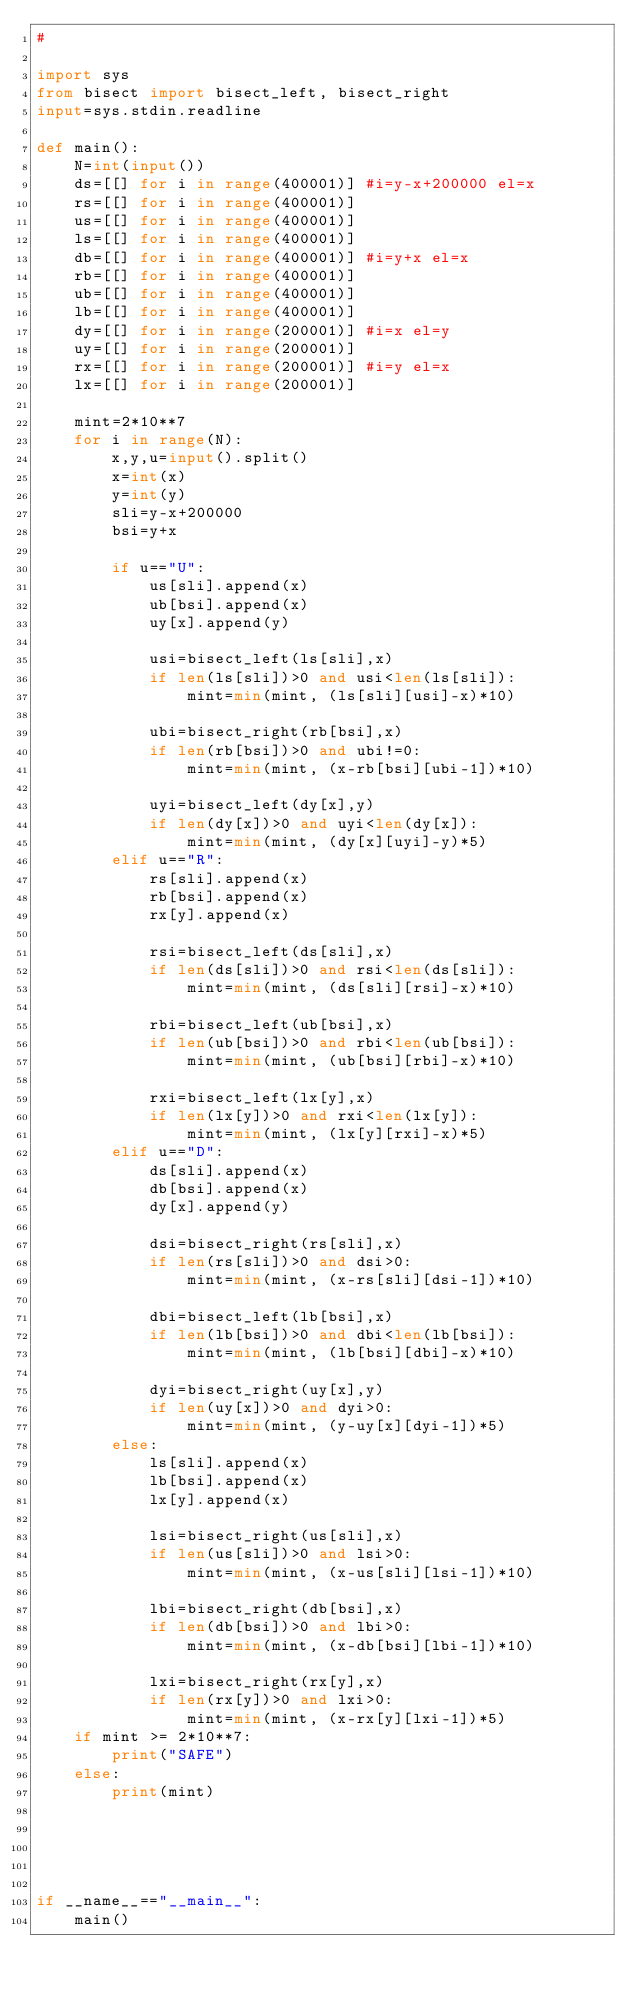<code> <loc_0><loc_0><loc_500><loc_500><_Python_>#

import sys
from bisect import bisect_left, bisect_right
input=sys.stdin.readline

def main():
    N=int(input())
    ds=[[] for i in range(400001)] #i=y-x+200000 el=x
    rs=[[] for i in range(400001)]
    us=[[] for i in range(400001)]
    ls=[[] for i in range(400001)]
    db=[[] for i in range(400001)] #i=y+x el=x
    rb=[[] for i in range(400001)]
    ub=[[] for i in range(400001)]
    lb=[[] for i in range(400001)]
    dy=[[] for i in range(200001)] #i=x el=y
    uy=[[] for i in range(200001)]
    rx=[[] for i in range(200001)] #i=y el=x
    lx=[[] for i in range(200001)]
    
    mint=2*10**7
    for i in range(N):
        x,y,u=input().split()
        x=int(x)
        y=int(y)
        sli=y-x+200000
        bsi=y+x
        
        if u=="U":
            us[sli].append(x)
            ub[bsi].append(x)
            uy[x].append(y)
            
            usi=bisect_left(ls[sli],x)
            if len(ls[sli])>0 and usi<len(ls[sli]):
                mint=min(mint, (ls[sli][usi]-x)*10)
                
            ubi=bisect_right(rb[bsi],x)
            if len(rb[bsi])>0 and ubi!=0:
                mint=min(mint, (x-rb[bsi][ubi-1])*10)
                
            uyi=bisect_left(dy[x],y)
            if len(dy[x])>0 and uyi<len(dy[x]):
                mint=min(mint, (dy[x][uyi]-y)*5)
        elif u=="R":
            rs[sli].append(x)
            rb[bsi].append(x)
            rx[y].append(x)
            
            rsi=bisect_left(ds[sli],x)
            if len(ds[sli])>0 and rsi<len(ds[sli]):
                mint=min(mint, (ds[sli][rsi]-x)*10)
            
            rbi=bisect_left(ub[bsi],x)
            if len(ub[bsi])>0 and rbi<len(ub[bsi]):
                mint=min(mint, (ub[bsi][rbi]-x)*10)
            
            rxi=bisect_left(lx[y],x)
            if len(lx[y])>0 and rxi<len(lx[y]):
                mint=min(mint, (lx[y][rxi]-x)*5)
        elif u=="D":
            ds[sli].append(x)
            db[bsi].append(x)
            dy[x].append(y)
            
            dsi=bisect_right(rs[sli],x)
            if len(rs[sli])>0 and dsi>0:
                mint=min(mint, (x-rs[sli][dsi-1])*10)
            
            dbi=bisect_left(lb[bsi],x)
            if len(lb[bsi])>0 and dbi<len(lb[bsi]):
                mint=min(mint, (lb[bsi][dbi]-x)*10)
            
            dyi=bisect_right(uy[x],y)
            if len(uy[x])>0 and dyi>0:
                mint=min(mint, (y-uy[x][dyi-1])*5)
        else:
            ls[sli].append(x)
            lb[bsi].append(x)
            lx[y].append(x)
            
            lsi=bisect_right(us[sli],x)
            if len(us[sli])>0 and lsi>0:
                mint=min(mint, (x-us[sli][lsi-1])*10)
            
            lbi=bisect_right(db[bsi],x)
            if len(db[bsi])>0 and lbi>0:
                mint=min(mint, (x-db[bsi][lbi-1])*10)
            
            lxi=bisect_right(rx[y],x)
            if len(rx[y])>0 and lxi>0:
                mint=min(mint, (x-rx[y][lxi-1])*5)
    if mint >= 2*10**7:
        print("SAFE")
    else:
        print(mint)
                
                
    
    
    
if __name__=="__main__":
    main()
</code> 